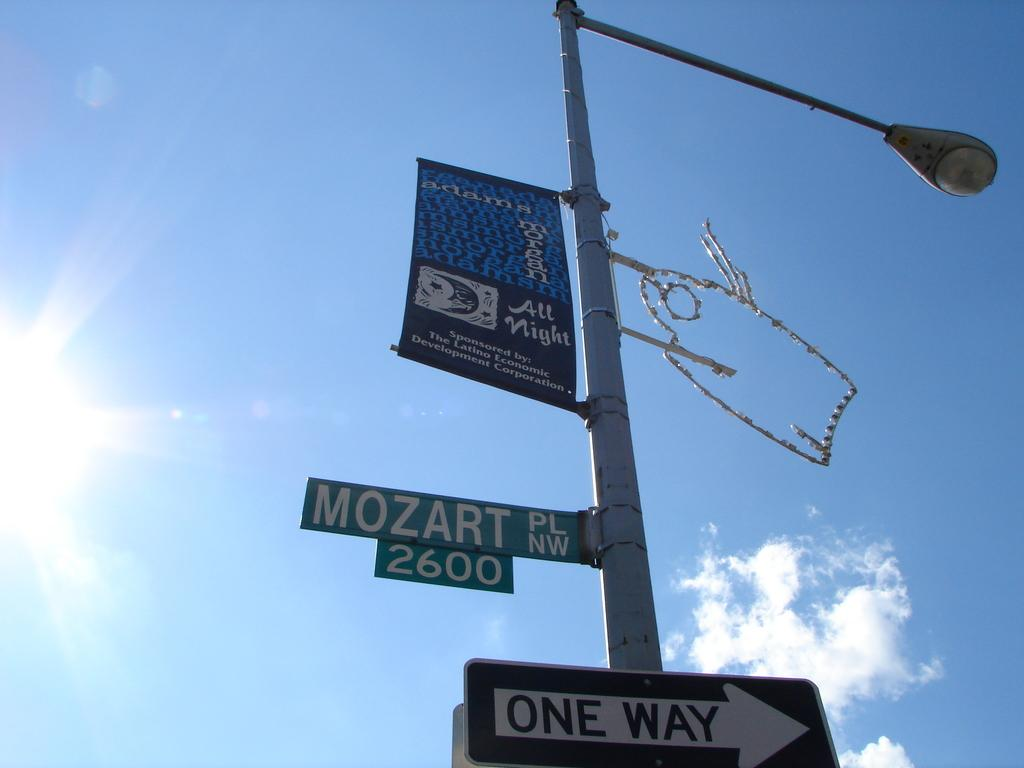<image>
Describe the image concisely. An advertisment for Adams Morgan is above a One Way street sign. 